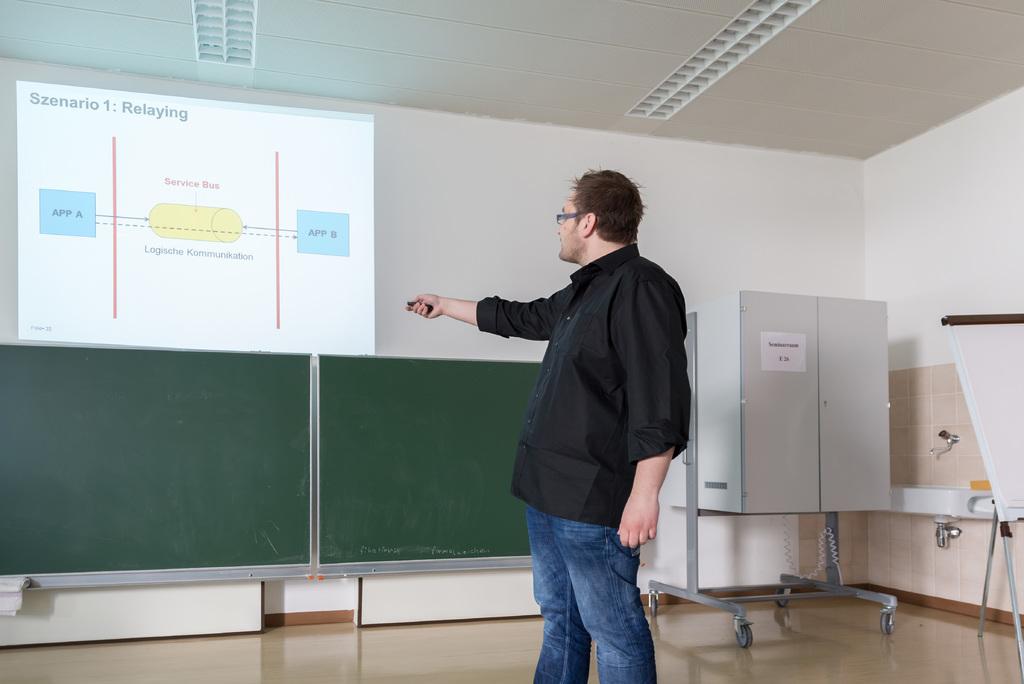What is the title of the presentation?
Ensure brevity in your answer.  Szenario 1: relaying. What szenario is relaying?
Offer a very short reply. 1. 